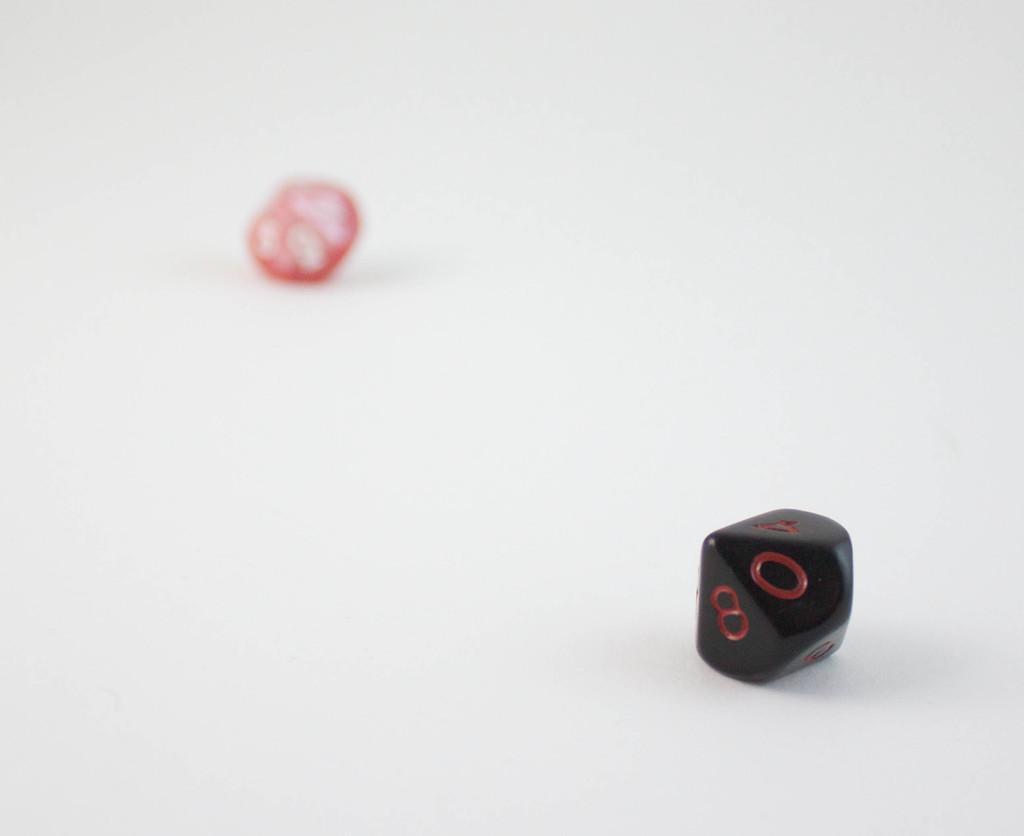In one or two sentences, can you explain what this image depicts? In this picture we can see two objects on the white surface. 